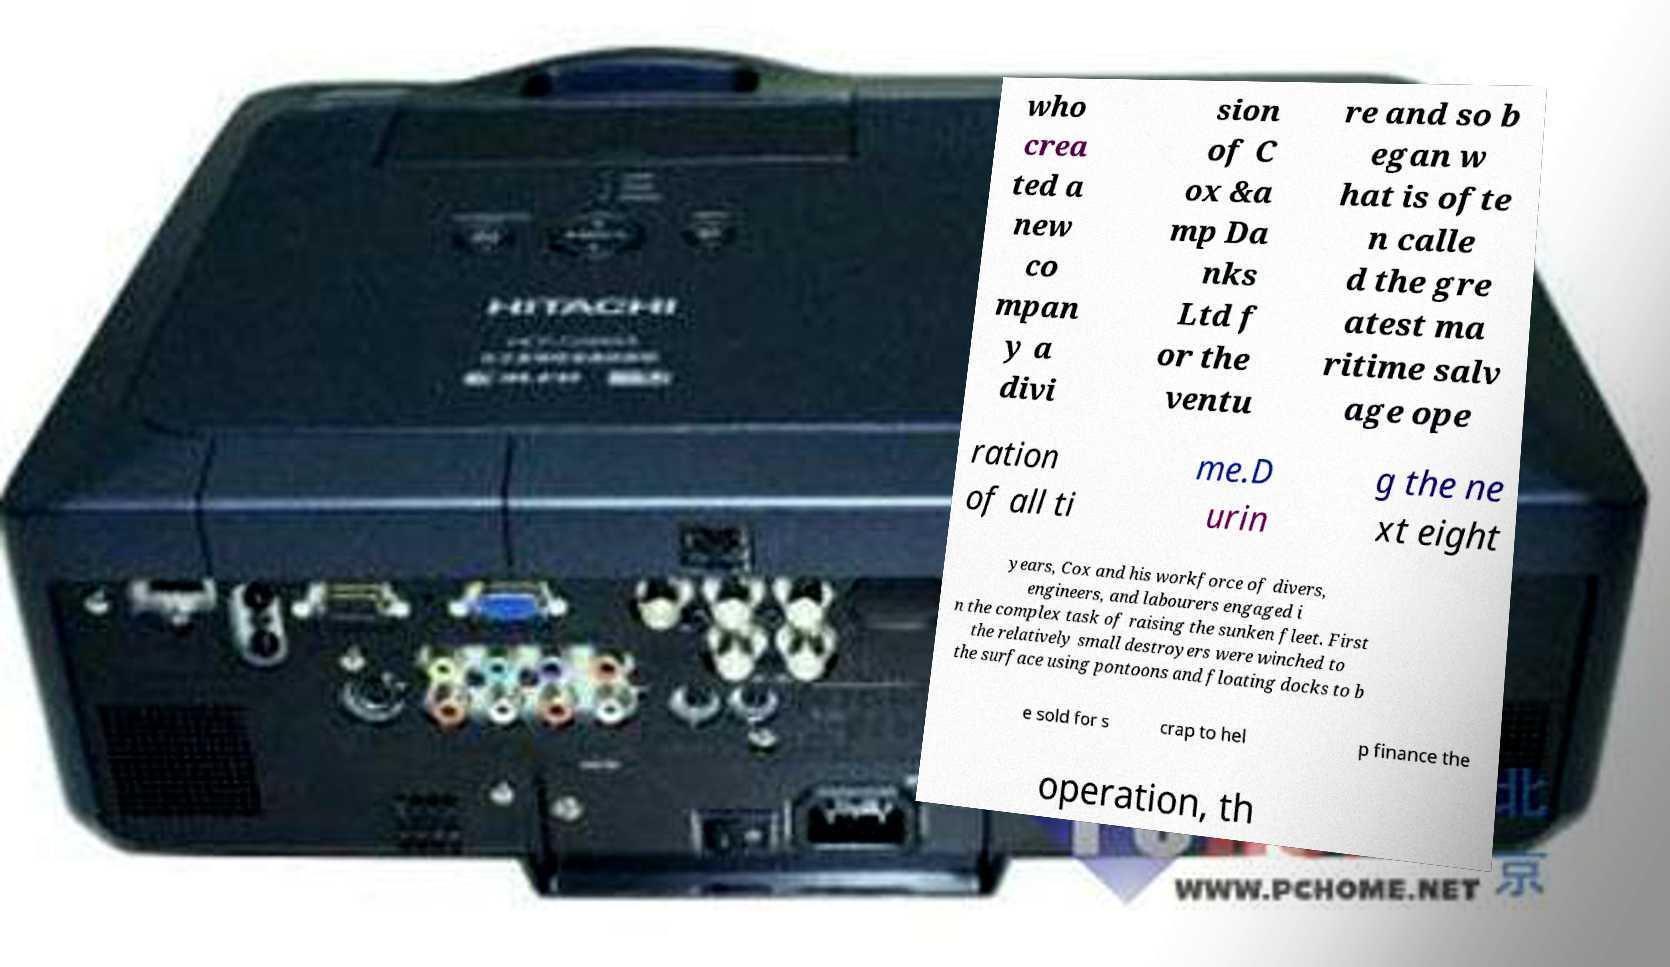Can you accurately transcribe the text from the provided image for me? who crea ted a new co mpan y a divi sion of C ox &a mp Da nks Ltd f or the ventu re and so b egan w hat is ofte n calle d the gre atest ma ritime salv age ope ration of all ti me.D urin g the ne xt eight years, Cox and his workforce of divers, engineers, and labourers engaged i n the complex task of raising the sunken fleet. First the relatively small destroyers were winched to the surface using pontoons and floating docks to b e sold for s crap to hel p finance the operation, th 